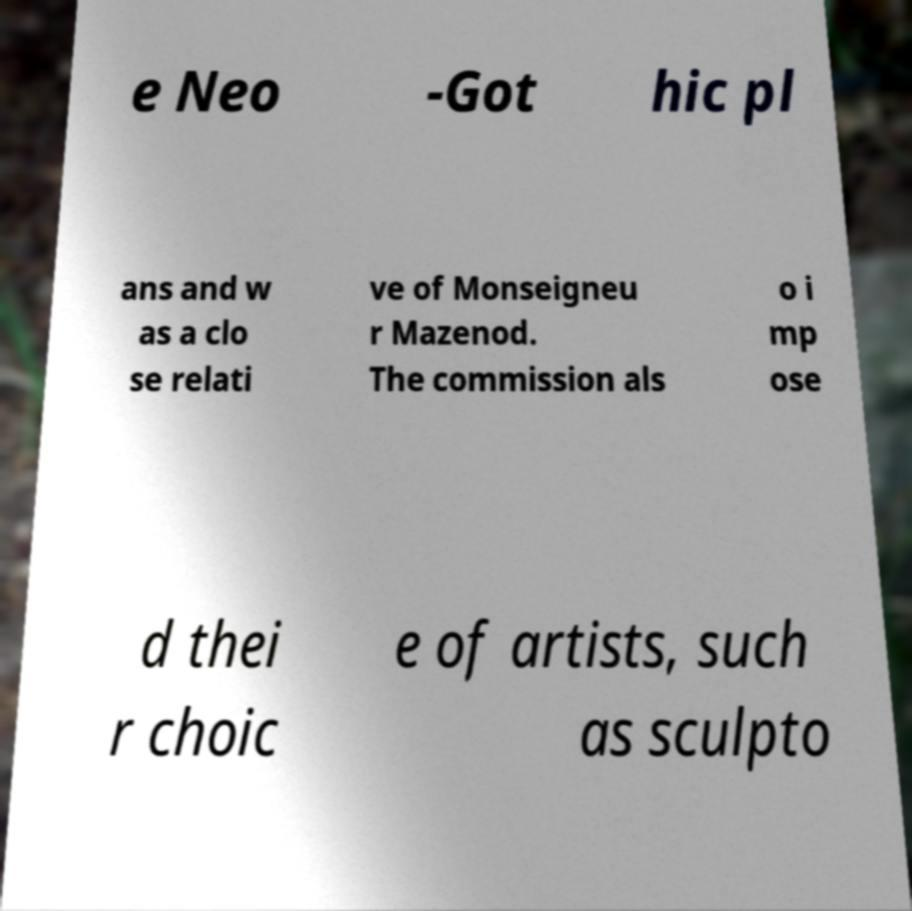Could you extract and type out the text from this image? e Neo -Got hic pl ans and w as a clo se relati ve of Monseigneu r Mazenod. The commission als o i mp ose d thei r choic e of artists, such as sculpto 